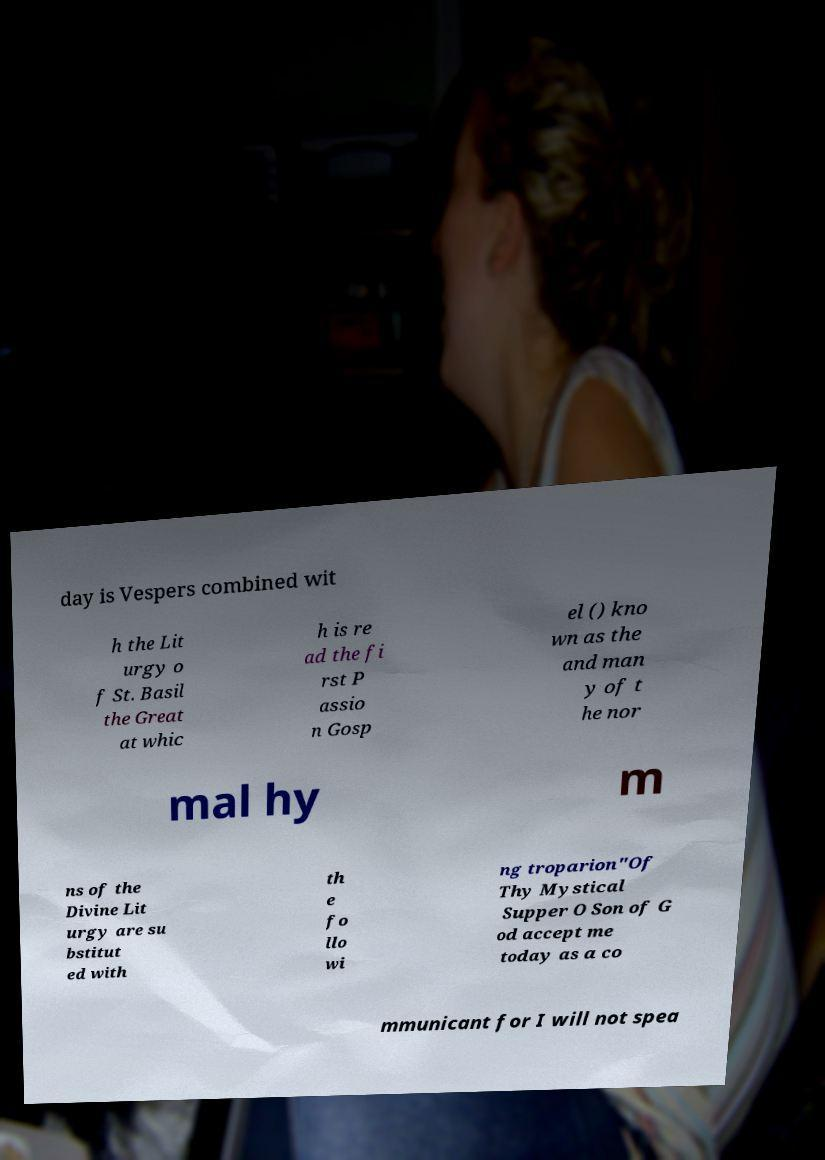Could you extract and type out the text from this image? day is Vespers combined wit h the Lit urgy o f St. Basil the Great at whic h is re ad the fi rst P assio n Gosp el () kno wn as the and man y of t he nor mal hy m ns of the Divine Lit urgy are su bstitut ed with th e fo llo wi ng troparion"Of Thy Mystical Supper O Son of G od accept me today as a co mmunicant for I will not spea 